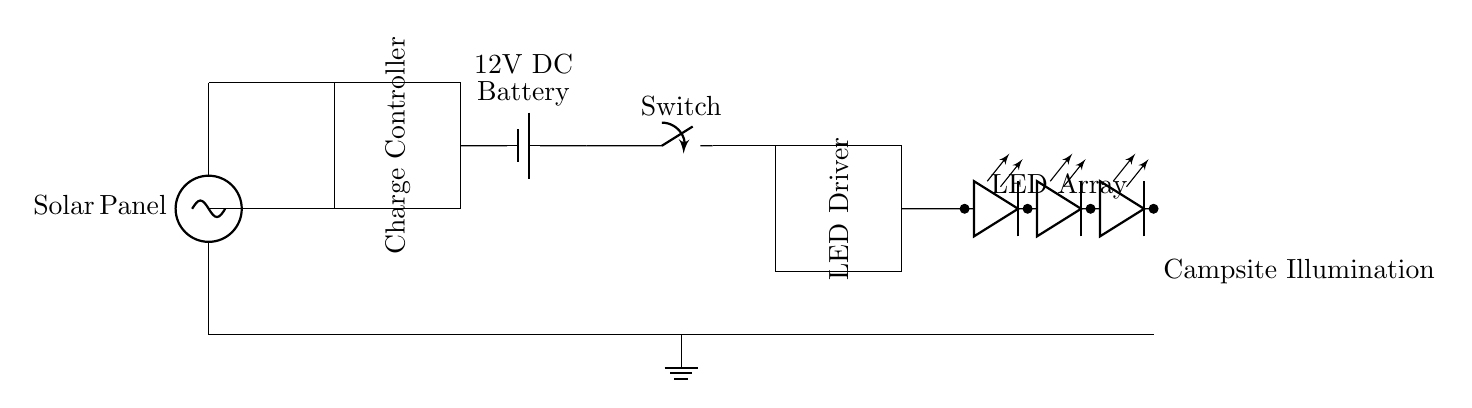What type of solar panel is used? The circuit diagram does not specify the type of solar panel, but it generally indicates a solar panel as a voltage source.
Answer: Solar Panel What is the function of the charge controller? The charge controller regulates the voltage and current coming from the solar panel to the battery, preventing overcharging.
Answer: Regulation What is the voltage of the battery? The label next to the battery indicates it is a 12V battery.
Answer: 12V How many LEDs are in the array? The LED array consists of four individual LEDs in series, as depicted in the diagram.
Answer: Four What is the main purpose of this circuit? The primary purpose of the circuit is to illuminate a campsite using LED lights powered by solar energy.
Answer: Campsite Illumination What happens when the switch is open? When the switch is open, it breaks the circuit, stopping current flow from the battery to the LED driver and LEDs, thus turning off the lights.
Answer: No Illumination 